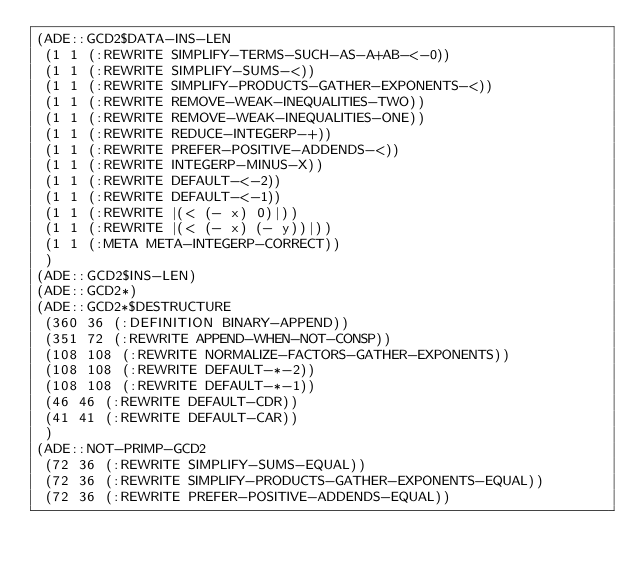<code> <loc_0><loc_0><loc_500><loc_500><_Lisp_>(ADE::GCD2$DATA-INS-LEN
 (1 1 (:REWRITE SIMPLIFY-TERMS-SUCH-AS-A+AB-<-0))
 (1 1 (:REWRITE SIMPLIFY-SUMS-<))
 (1 1 (:REWRITE SIMPLIFY-PRODUCTS-GATHER-EXPONENTS-<))
 (1 1 (:REWRITE REMOVE-WEAK-INEQUALITIES-TWO))
 (1 1 (:REWRITE REMOVE-WEAK-INEQUALITIES-ONE))
 (1 1 (:REWRITE REDUCE-INTEGERP-+))
 (1 1 (:REWRITE PREFER-POSITIVE-ADDENDS-<))
 (1 1 (:REWRITE INTEGERP-MINUS-X))
 (1 1 (:REWRITE DEFAULT-<-2))
 (1 1 (:REWRITE DEFAULT-<-1))
 (1 1 (:REWRITE |(< (- x) 0)|))
 (1 1 (:REWRITE |(< (- x) (- y))|))
 (1 1 (:META META-INTEGERP-CORRECT))
 )
(ADE::GCD2$INS-LEN)
(ADE::GCD2*)
(ADE::GCD2*$DESTRUCTURE
 (360 36 (:DEFINITION BINARY-APPEND))
 (351 72 (:REWRITE APPEND-WHEN-NOT-CONSP))
 (108 108 (:REWRITE NORMALIZE-FACTORS-GATHER-EXPONENTS))
 (108 108 (:REWRITE DEFAULT-*-2))
 (108 108 (:REWRITE DEFAULT-*-1))
 (46 46 (:REWRITE DEFAULT-CDR))
 (41 41 (:REWRITE DEFAULT-CAR))
 )
(ADE::NOT-PRIMP-GCD2
 (72 36 (:REWRITE SIMPLIFY-SUMS-EQUAL))
 (72 36 (:REWRITE SIMPLIFY-PRODUCTS-GATHER-EXPONENTS-EQUAL))
 (72 36 (:REWRITE PREFER-POSITIVE-ADDENDS-EQUAL))</code> 